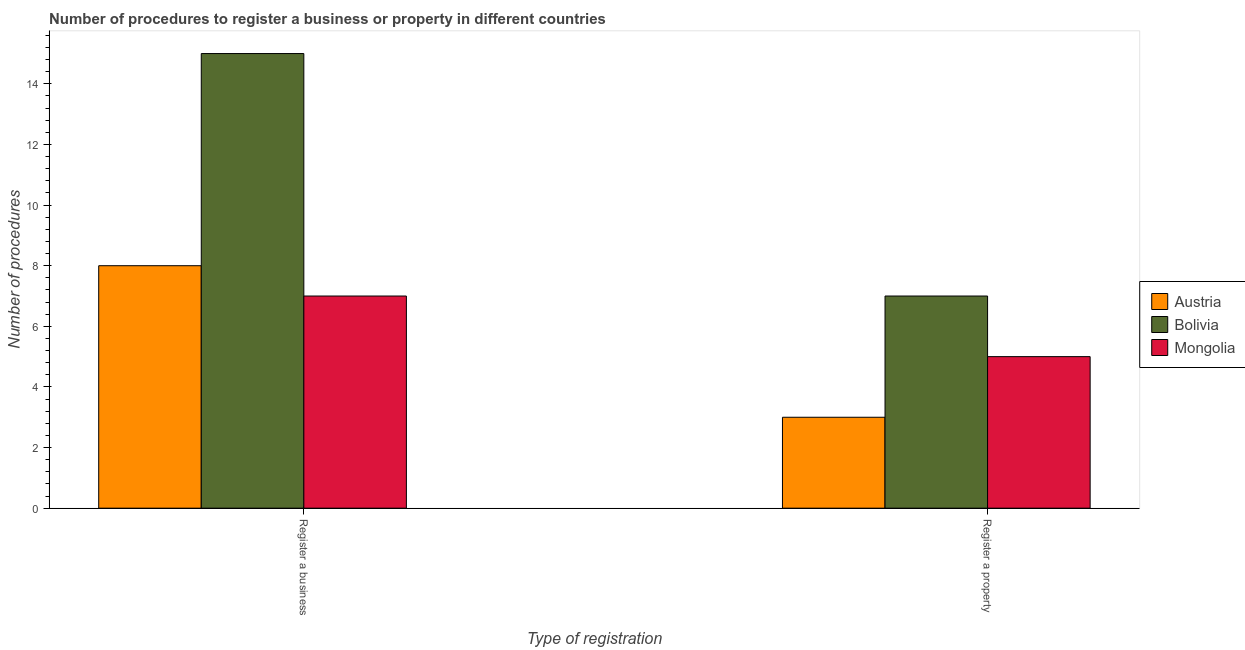How many groups of bars are there?
Offer a terse response. 2. Are the number of bars per tick equal to the number of legend labels?
Provide a succinct answer. Yes. Are the number of bars on each tick of the X-axis equal?
Provide a short and direct response. Yes. How many bars are there on the 2nd tick from the left?
Provide a short and direct response. 3. What is the label of the 2nd group of bars from the left?
Provide a short and direct response. Register a property. What is the number of procedures to register a business in Mongolia?
Offer a terse response. 7. Across all countries, what is the maximum number of procedures to register a property?
Make the answer very short. 7. Across all countries, what is the minimum number of procedures to register a business?
Make the answer very short. 7. What is the total number of procedures to register a property in the graph?
Your response must be concise. 15. What is the difference between the number of procedures to register a property in Mongolia and that in Austria?
Ensure brevity in your answer.  2. What is the difference between the number of procedures to register a property in Mongolia and the number of procedures to register a business in Austria?
Provide a short and direct response. -3. What is the average number of procedures to register a property per country?
Ensure brevity in your answer.  5. What is the difference between the number of procedures to register a property and number of procedures to register a business in Mongolia?
Make the answer very short. -2. Is the number of procedures to register a business in Bolivia less than that in Austria?
Give a very brief answer. No. How many bars are there?
Give a very brief answer. 6. How many countries are there in the graph?
Keep it short and to the point. 3. Are the values on the major ticks of Y-axis written in scientific E-notation?
Provide a succinct answer. No. Does the graph contain any zero values?
Keep it short and to the point. No. Does the graph contain grids?
Your answer should be very brief. No. How are the legend labels stacked?
Give a very brief answer. Vertical. What is the title of the graph?
Make the answer very short. Number of procedures to register a business or property in different countries. What is the label or title of the X-axis?
Ensure brevity in your answer.  Type of registration. What is the label or title of the Y-axis?
Give a very brief answer. Number of procedures. What is the Number of procedures in Bolivia in Register a business?
Offer a terse response. 15. What is the Number of procedures in Mongolia in Register a business?
Offer a terse response. 7. What is the Number of procedures in Austria in Register a property?
Ensure brevity in your answer.  3. What is the Number of procedures of Bolivia in Register a property?
Offer a terse response. 7. Across all Type of registration, what is the maximum Number of procedures of Austria?
Offer a terse response. 8. Across all Type of registration, what is the maximum Number of procedures of Bolivia?
Offer a very short reply. 15. Across all Type of registration, what is the minimum Number of procedures of Mongolia?
Provide a short and direct response. 5. What is the total Number of procedures of Mongolia in the graph?
Your answer should be very brief. 12. What is the difference between the Number of procedures of Bolivia in Register a business and that in Register a property?
Your response must be concise. 8. What is the difference between the Number of procedures in Mongolia in Register a business and that in Register a property?
Make the answer very short. 2. What is the difference between the Number of procedures of Bolivia in Register a business and the Number of procedures of Mongolia in Register a property?
Offer a very short reply. 10. What is the average Number of procedures of Austria per Type of registration?
Provide a succinct answer. 5.5. What is the average Number of procedures in Bolivia per Type of registration?
Your response must be concise. 11. What is the average Number of procedures in Mongolia per Type of registration?
Ensure brevity in your answer.  6. What is the difference between the Number of procedures of Austria and Number of procedures of Bolivia in Register a business?
Keep it short and to the point. -7. What is the difference between the Number of procedures of Austria and Number of procedures of Mongolia in Register a business?
Your response must be concise. 1. What is the difference between the Number of procedures of Bolivia and Number of procedures of Mongolia in Register a business?
Your answer should be compact. 8. What is the difference between the Number of procedures in Austria and Number of procedures in Bolivia in Register a property?
Your response must be concise. -4. What is the ratio of the Number of procedures in Austria in Register a business to that in Register a property?
Provide a succinct answer. 2.67. What is the ratio of the Number of procedures of Bolivia in Register a business to that in Register a property?
Offer a terse response. 2.14. What is the ratio of the Number of procedures of Mongolia in Register a business to that in Register a property?
Your response must be concise. 1.4. What is the difference between the highest and the second highest Number of procedures of Austria?
Ensure brevity in your answer.  5. What is the difference between the highest and the second highest Number of procedures of Mongolia?
Make the answer very short. 2. What is the difference between the highest and the lowest Number of procedures in Bolivia?
Offer a terse response. 8. 